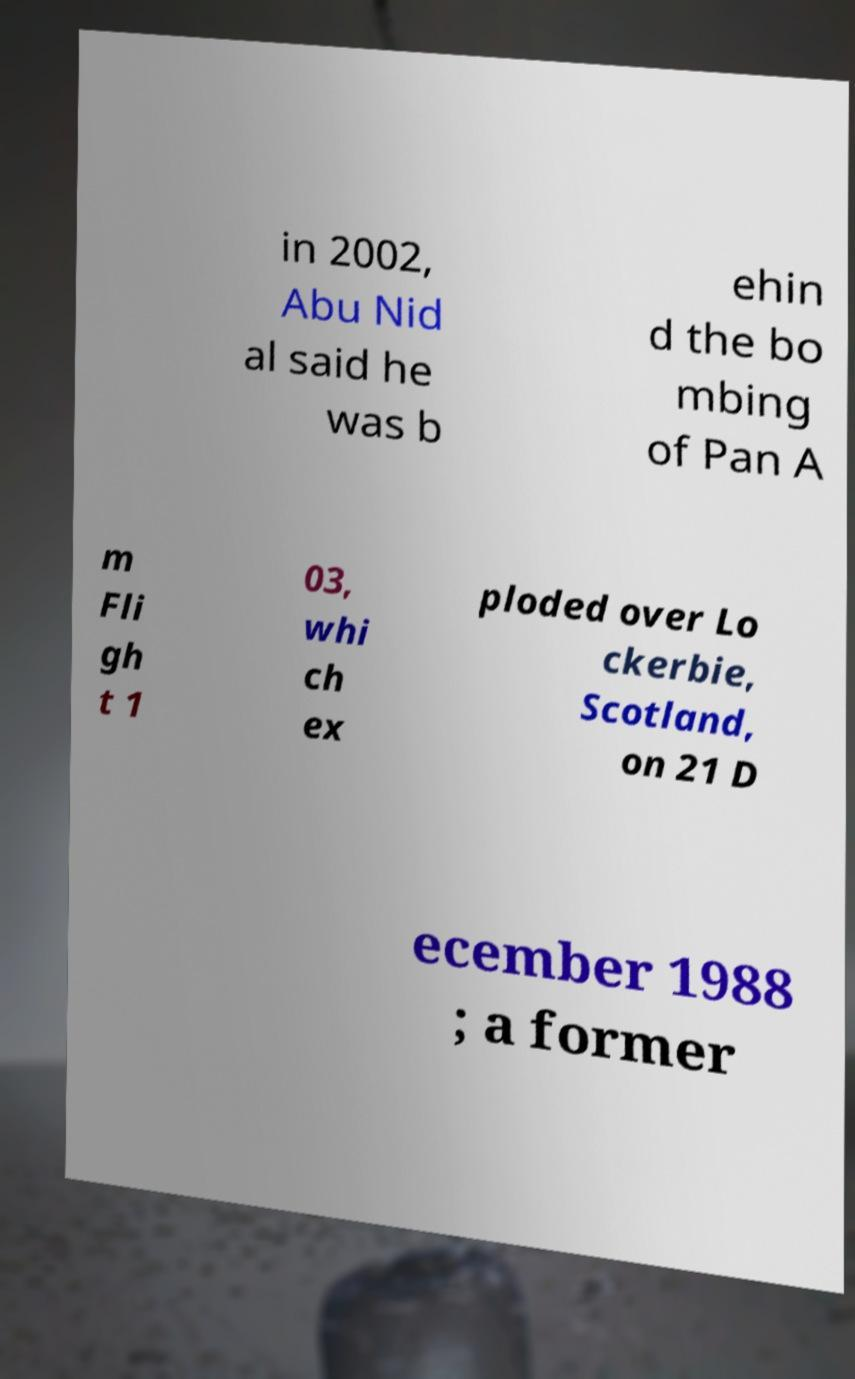Please identify and transcribe the text found in this image. in 2002, Abu Nid al said he was b ehin d the bo mbing of Pan A m Fli gh t 1 03, whi ch ex ploded over Lo ckerbie, Scotland, on 21 D ecember 1988 ; a former 